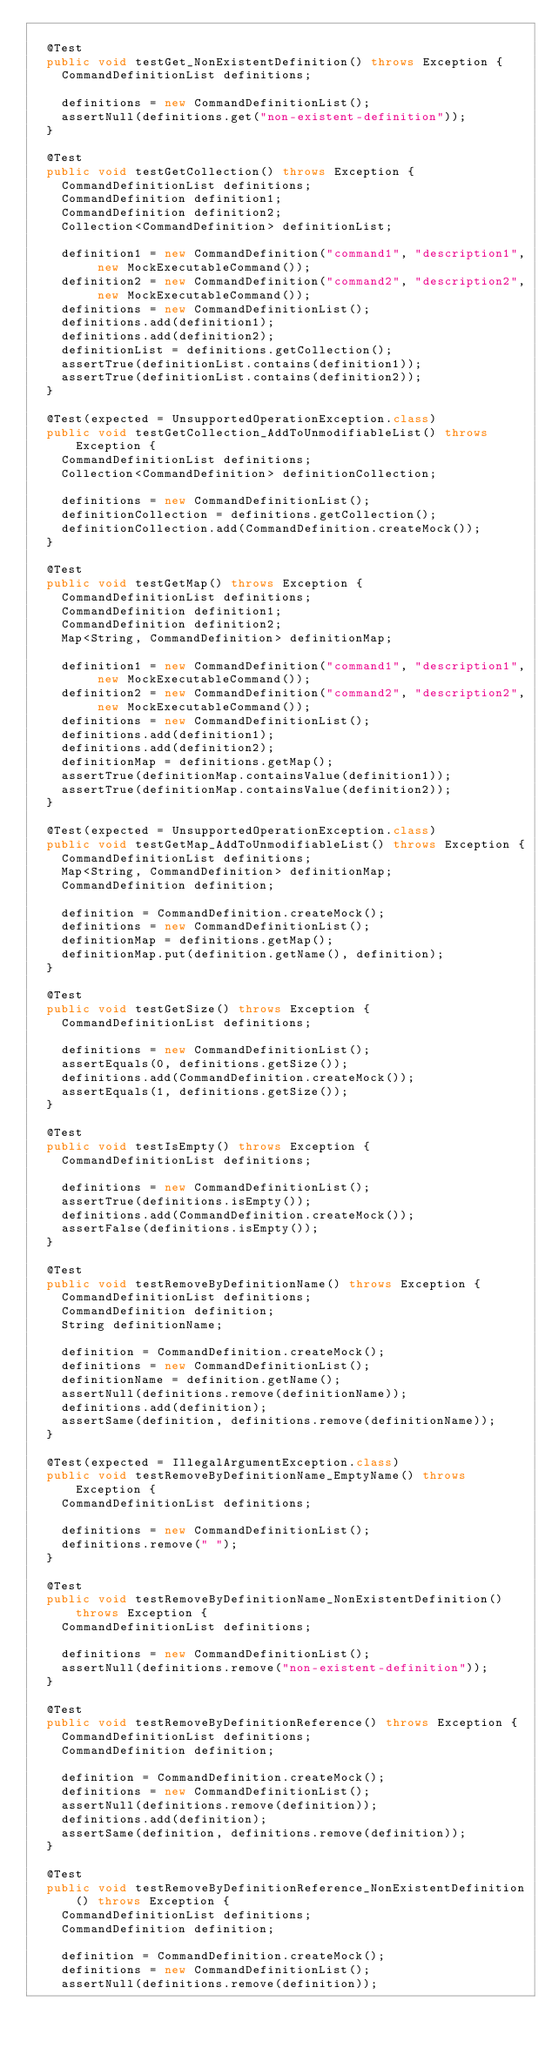Convert code to text. <code><loc_0><loc_0><loc_500><loc_500><_Java_>
	@Test
	public void testGet_NonExistentDefinition() throws Exception {
		CommandDefinitionList definitions;

		definitions = new CommandDefinitionList();
		assertNull(definitions.get("non-existent-definition"));
	}

	@Test
	public void testGetCollection() throws Exception {
		CommandDefinitionList definitions;
		CommandDefinition definition1;
		CommandDefinition definition2;
		Collection<CommandDefinition> definitionList;

		definition1 = new CommandDefinition("command1", "description1", new MockExecutableCommand());
		definition2 = new CommandDefinition("command2", "description2", new MockExecutableCommand());
		definitions = new CommandDefinitionList();
		definitions.add(definition1);
		definitions.add(definition2);
		definitionList = definitions.getCollection();
		assertTrue(definitionList.contains(definition1));
		assertTrue(definitionList.contains(definition2));
	}

	@Test(expected = UnsupportedOperationException.class)
	public void testGetCollection_AddToUnmodifiableList() throws Exception {
		CommandDefinitionList definitions;
		Collection<CommandDefinition> definitionCollection;

		definitions = new CommandDefinitionList();
		definitionCollection = definitions.getCollection();
		definitionCollection.add(CommandDefinition.createMock());
	}

	@Test
	public void testGetMap() throws Exception {
		CommandDefinitionList definitions;
		CommandDefinition definition1;
		CommandDefinition definition2;
		Map<String, CommandDefinition> definitionMap;

		definition1 = new CommandDefinition("command1", "description1", new MockExecutableCommand());
		definition2 = new CommandDefinition("command2", "description2", new MockExecutableCommand());
		definitions = new CommandDefinitionList();
		definitions.add(definition1);
		definitions.add(definition2);
		definitionMap = definitions.getMap();
		assertTrue(definitionMap.containsValue(definition1));
		assertTrue(definitionMap.containsValue(definition2));
	}

	@Test(expected = UnsupportedOperationException.class)
	public void testGetMap_AddToUnmodifiableList() throws Exception {
		CommandDefinitionList definitions;
		Map<String, CommandDefinition> definitionMap;
		CommandDefinition definition;

		definition = CommandDefinition.createMock();
		definitions = new CommandDefinitionList();
		definitionMap = definitions.getMap();
		definitionMap.put(definition.getName(), definition);
	}

	@Test
	public void testGetSize() throws Exception {
		CommandDefinitionList definitions;

		definitions = new CommandDefinitionList();
		assertEquals(0, definitions.getSize());
		definitions.add(CommandDefinition.createMock());
		assertEquals(1, definitions.getSize());
	}

	@Test
	public void testIsEmpty() throws Exception {
		CommandDefinitionList definitions;

		definitions = new CommandDefinitionList();
		assertTrue(definitions.isEmpty());
		definitions.add(CommandDefinition.createMock());
		assertFalse(definitions.isEmpty());
	}

	@Test
	public void testRemoveByDefinitionName() throws Exception {
		CommandDefinitionList definitions;
		CommandDefinition definition;
		String definitionName;

		definition = CommandDefinition.createMock();
		definitions = new CommandDefinitionList();
		definitionName = definition.getName();
		assertNull(definitions.remove(definitionName));
		definitions.add(definition);
		assertSame(definition, definitions.remove(definitionName));
	}

	@Test(expected = IllegalArgumentException.class)
	public void testRemoveByDefinitionName_EmptyName() throws Exception {
		CommandDefinitionList definitions;

		definitions = new CommandDefinitionList();
		definitions.remove(" ");
	}

	@Test
	public void testRemoveByDefinitionName_NonExistentDefinition() throws Exception {
		CommandDefinitionList definitions;

		definitions = new CommandDefinitionList();
		assertNull(definitions.remove("non-existent-definition"));
	}

	@Test
	public void testRemoveByDefinitionReference() throws Exception {
		CommandDefinitionList definitions;
		CommandDefinition definition;

		definition = CommandDefinition.createMock();
		definitions = new CommandDefinitionList();
		assertNull(definitions.remove(definition));
		definitions.add(definition);
		assertSame(definition, definitions.remove(definition));
	}

	@Test
	public void testRemoveByDefinitionReference_NonExistentDefinition() throws Exception {
		CommandDefinitionList definitions;
		CommandDefinition definition;

		definition = CommandDefinition.createMock();
		definitions = new CommandDefinitionList();
		assertNull(definitions.remove(definition));</code> 